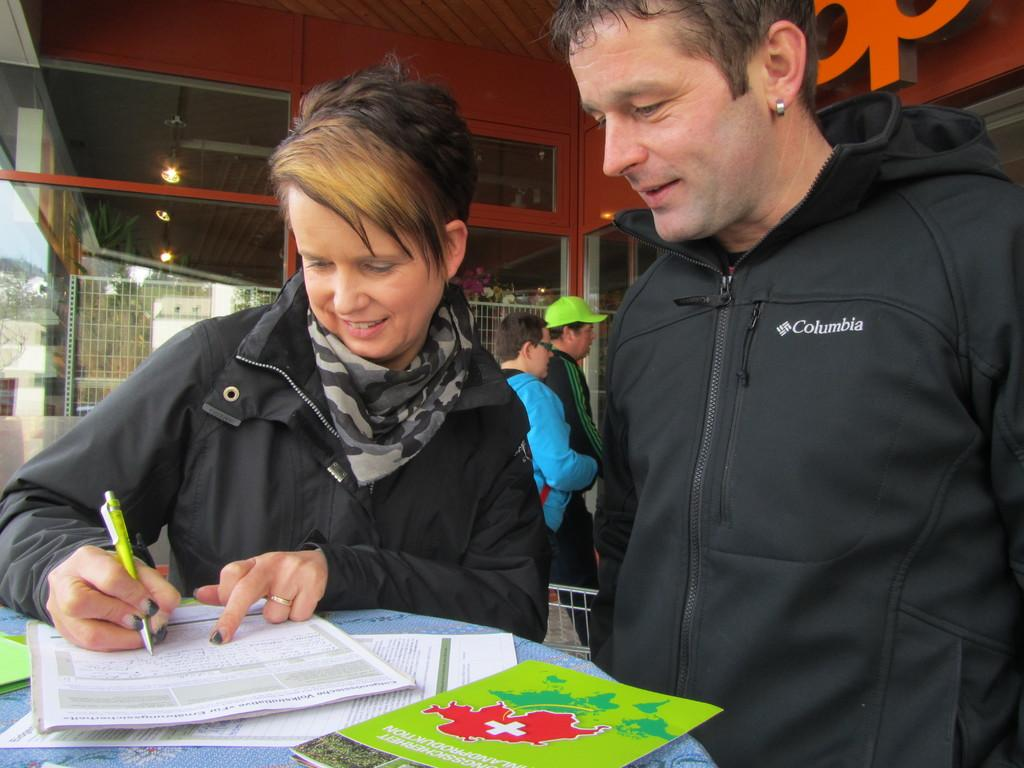What type of structure can be seen in the image? There is a wall in the image. What can be seen illuminating the area in the image? There are lights in the image. What type of barrier is present in the image? There is a fence in the image. Who or what is present in the image? There are people in the image. What is on the table in the image? There are papers and books on the table. What is the price of the books on the table in the image? There is no information about the price of the books in the image. Can you tell me how many friends are present in the image? The provided facts do not mention friends; there are only people present in the image. 